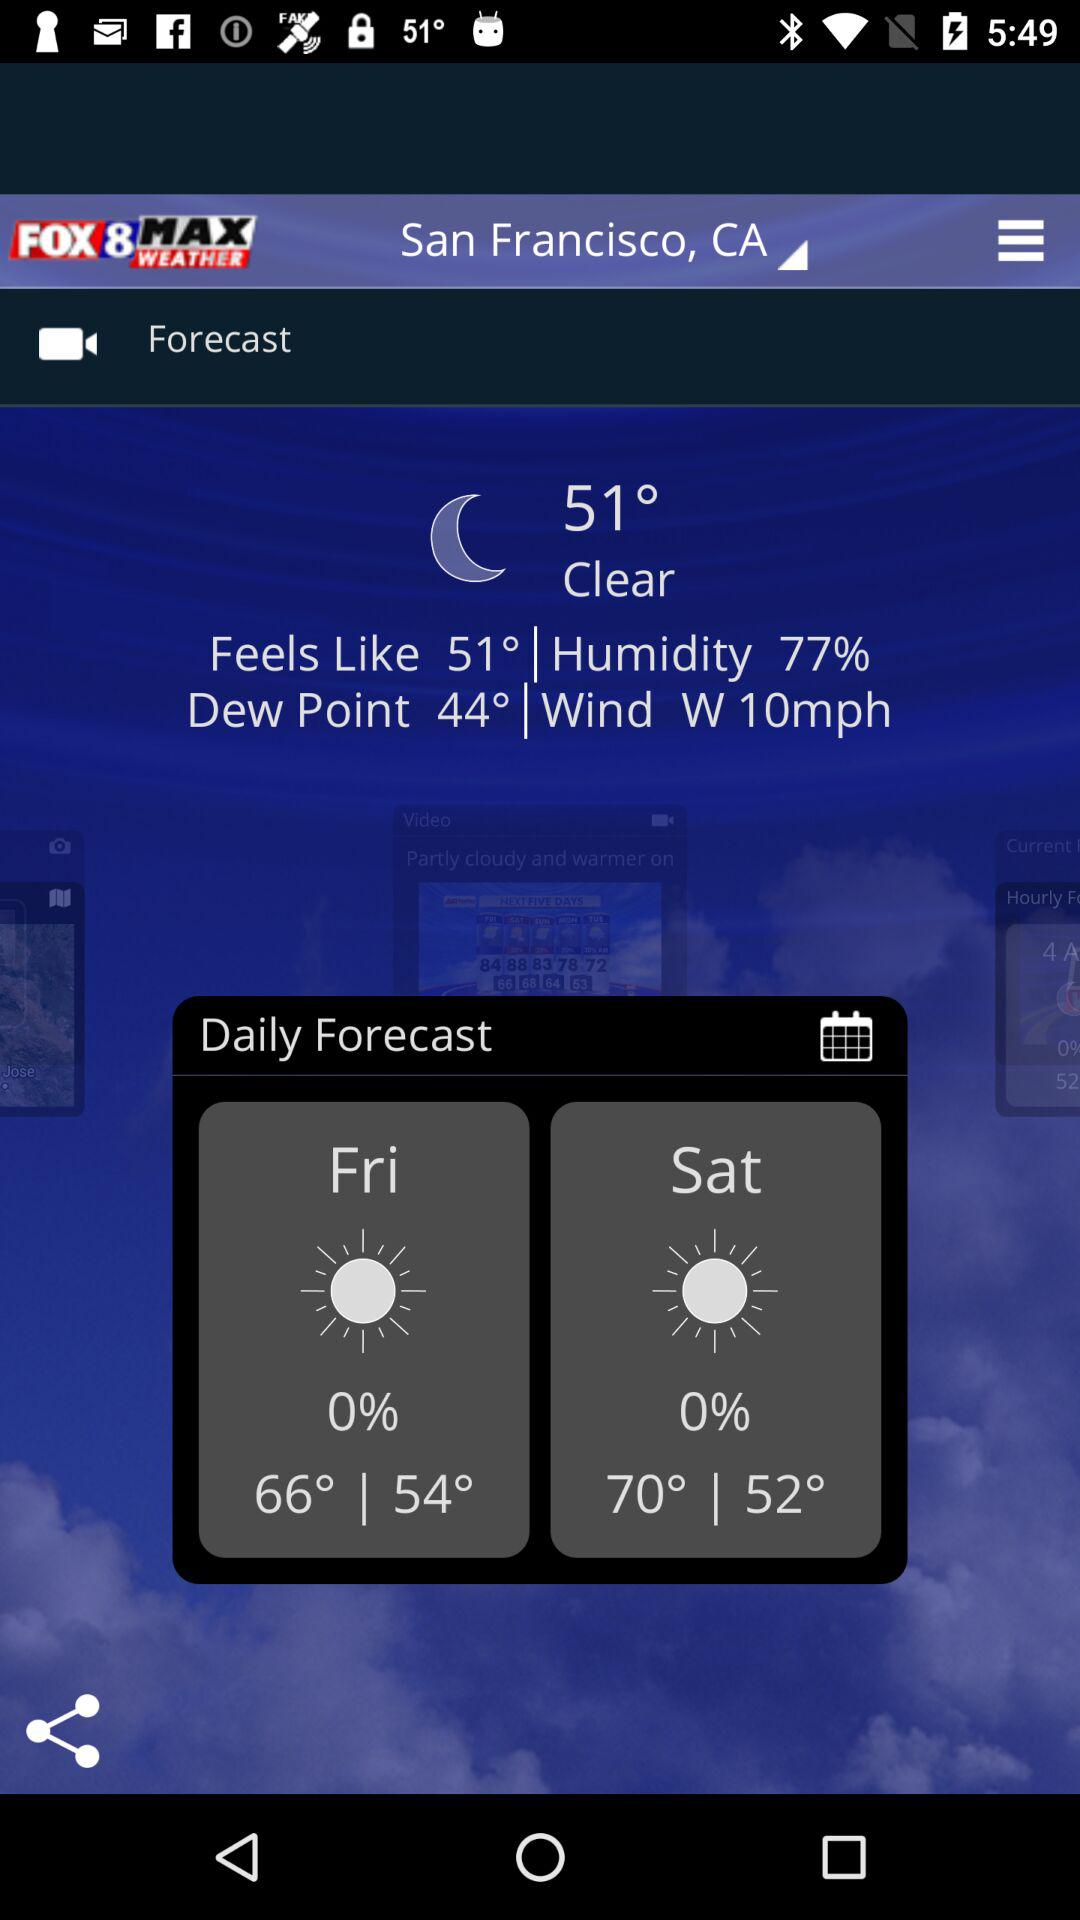What is the location? The location is San Francisco, CA. 